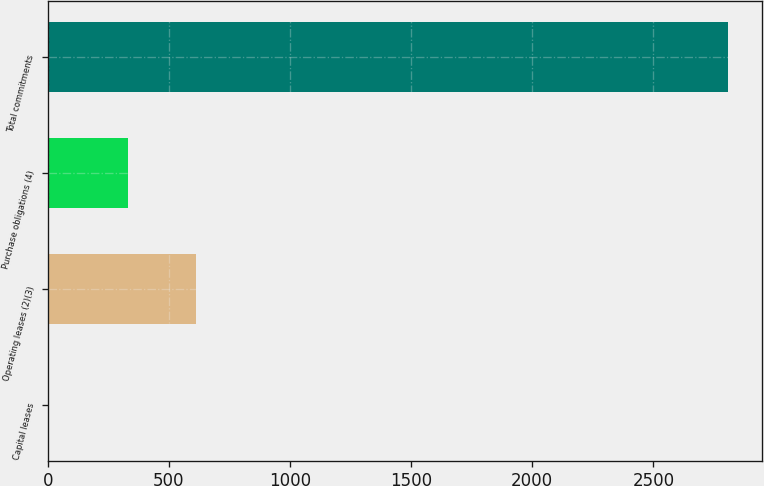<chart> <loc_0><loc_0><loc_500><loc_500><bar_chart><fcel>Capital leases<fcel>Operating leases (2)(3)<fcel>Purchase obligations (4)<fcel>Total commitments<nl><fcel>7<fcel>613.1<fcel>333<fcel>2808<nl></chart> 